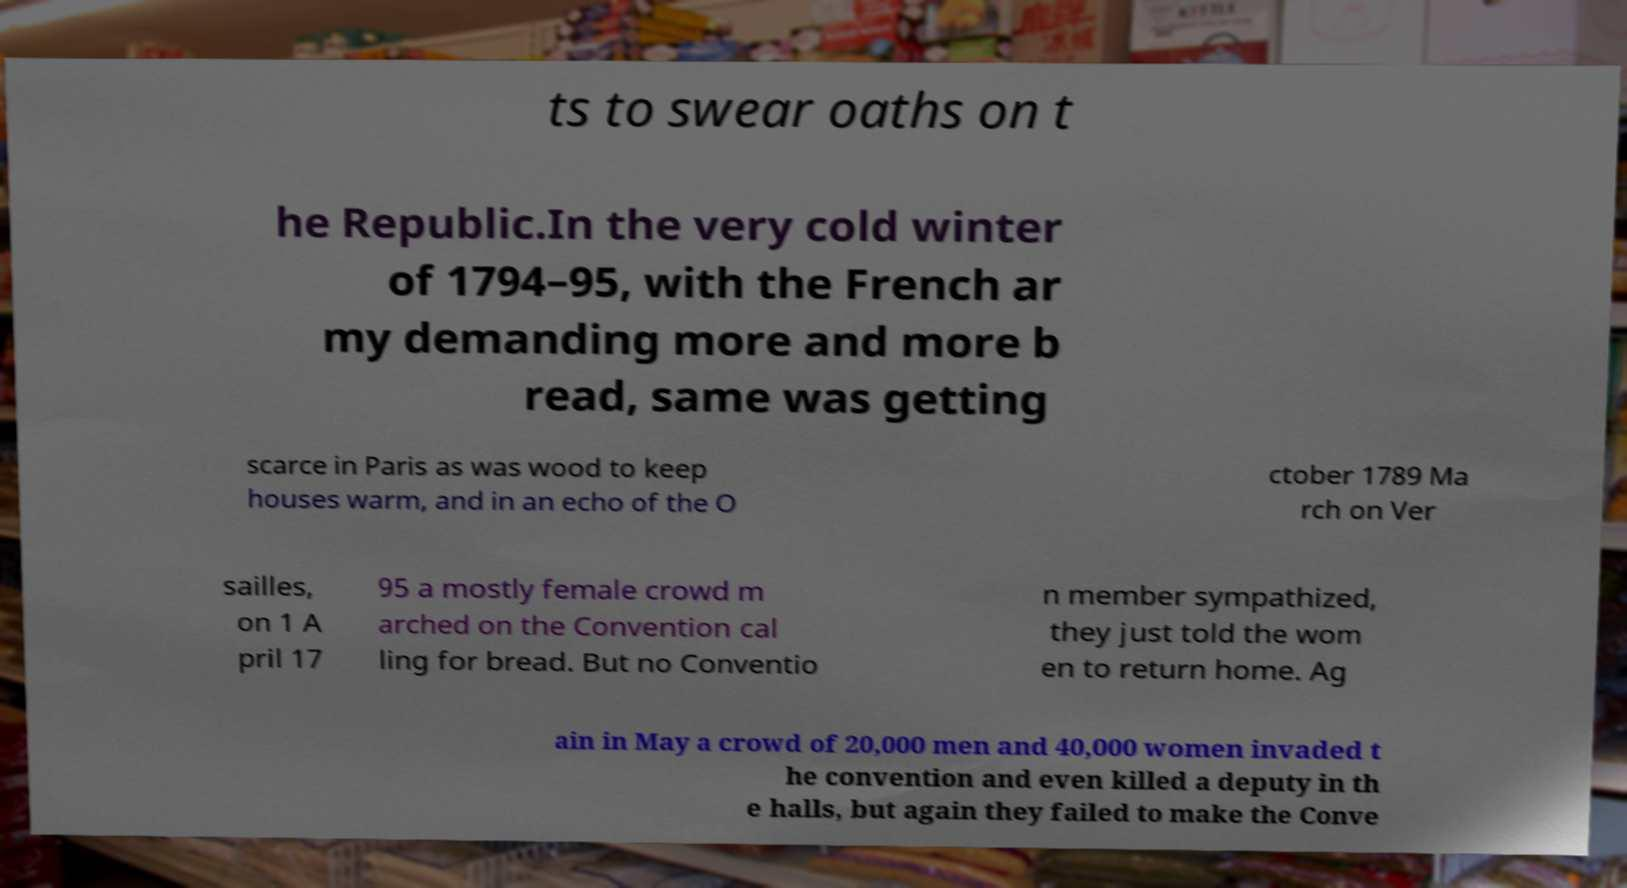Could you assist in decoding the text presented in this image and type it out clearly? ts to swear oaths on t he Republic.In the very cold winter of 1794–95, with the French ar my demanding more and more b read, same was getting scarce in Paris as was wood to keep houses warm, and in an echo of the O ctober 1789 Ma rch on Ver sailles, on 1 A pril 17 95 a mostly female crowd m arched on the Convention cal ling for bread. But no Conventio n member sympathized, they just told the wom en to return home. Ag ain in May a crowd of 20,000 men and 40,000 women invaded t he convention and even killed a deputy in th e halls, but again they failed to make the Conve 